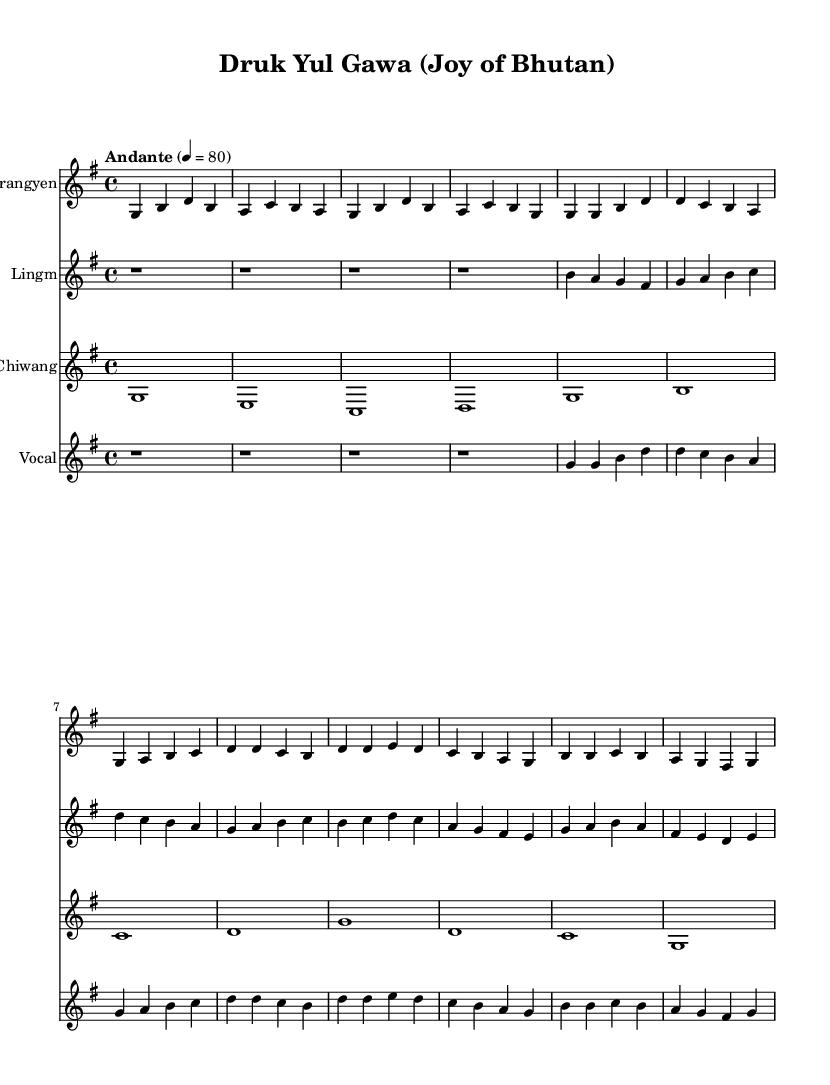What is the key signature of this music? The key signature is G major, which has one sharp (F#). This can be identified at the beginning of the sheet music where the key signature is notated.
Answer: G major What is the time signature of the piece? The time signature is 4/4, indicating that there are four beats in each measure. This is visible in the notation, where the time signature appears at the start.
Answer: 4/4 What is the tempo marking for this piece? The tempo marking is Andante, which indicates a moderate pace. It is explicitly written at the beginning of the score.
Answer: Andante How many measures are in the Drangyen part? The Drangyen part consists of 14 measures, as counted from the beginning to the end of the notation for that instrument.
Answer: 14 What is the primary vocal theme of this piece? The primary vocal theme includes the lyrics "Druk yul nang lu ga -- wa ki Chuk pai mi ser nga che yin." This is noted in the vocal staff section accompanied by the lyrics below the notes.
Answer: Druk yul nang lu ga -- wa ki Chuk pai mi ser nga che yin Which instrument has the lowest pitch in this arrangement? The Chiwang instrument plays the lowest pitch in this arrangement. This can be determined by examining the relative positioning of the notes on the staff.
Answer: Chiwang What type of music is represented by "Druk Yul Gawa"? This piece represents Traditional Bhutanese folk music, characterized by its specific lyrics and indigenous instruments used. The title and lyrics indicate its cultural background.
Answer: Traditional Bhutanese folk music 